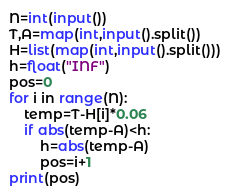Convert code to text. <code><loc_0><loc_0><loc_500><loc_500><_Python_>N=int(input())
T,A=map(int,input().split())
H=list(map(int,input().split()))
h=float("INF")
pos=0
for i in range(N):
    temp=T-H[i]*0.06
    if abs(temp-A)<h:
        h=abs(temp-A)
        pos=i+1
print(pos)</code> 